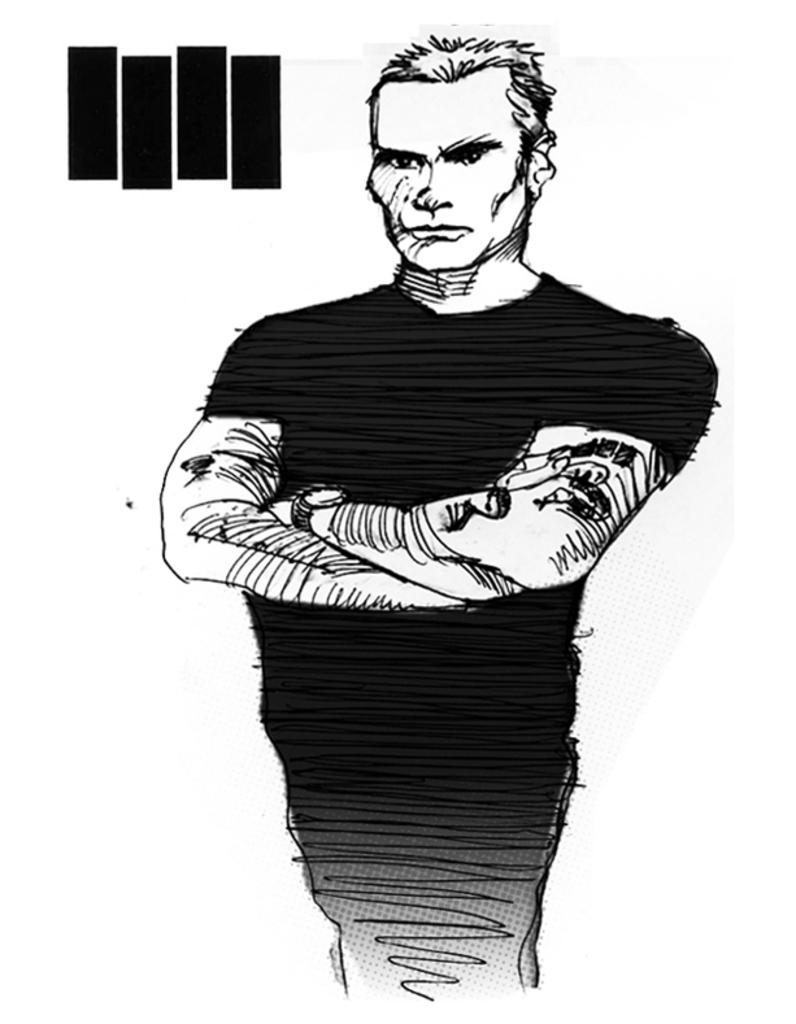What is depicted in the image? There is a sketch of a person in the image. What type of curve can be seen in the person's hair in the image? There is no curve visible in the person's hair in the image, as it is a sketch and not a photograph. 